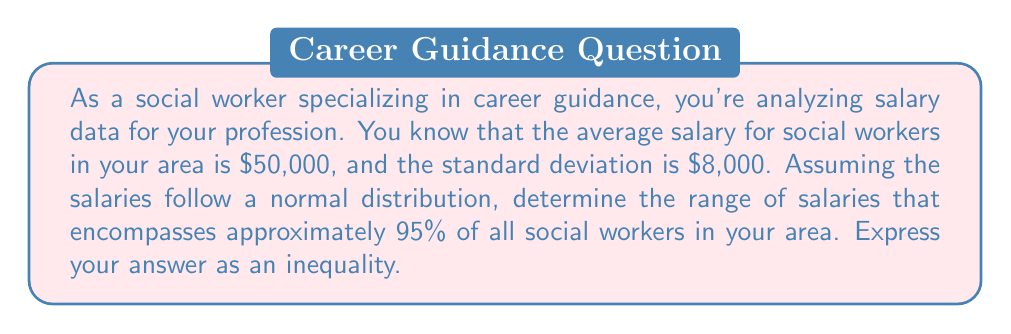Can you solve this math problem? To solve this problem, we'll use the properties of normal distribution and the concept of standard deviations:

1) In a normal distribution, approximately 95% of the data falls within 2 standard deviations of the mean.

2) Let's define our variables:
   $\mu$ = mean salary = $50,000
   $\sigma$ = standard deviation = $8,000

3) The range we're looking for is from $(\mu - 2\sigma)$ to $(\mu + 2\sigma)$

4) Lower bound: $\mu - 2\sigma = 50,000 - 2(8,000) = 50,000 - 16,000 = 34,000$

5) Upper bound: $\mu + 2\sigma = 50,000 + 2(8,000) = 50,000 + 16,000 = 66,000$

6) Therefore, approximately 95% of social workers in your area have salaries between $34,000 and $66,000.

7) We can express this as an inequality:

   $34,000 \leq \text{salary} \leq 66,000$

This inequality represents the range of salaries for approximately 95% of social workers in your area.
Answer: $34,000 \leq \text{salary} \leq 66,000$ 